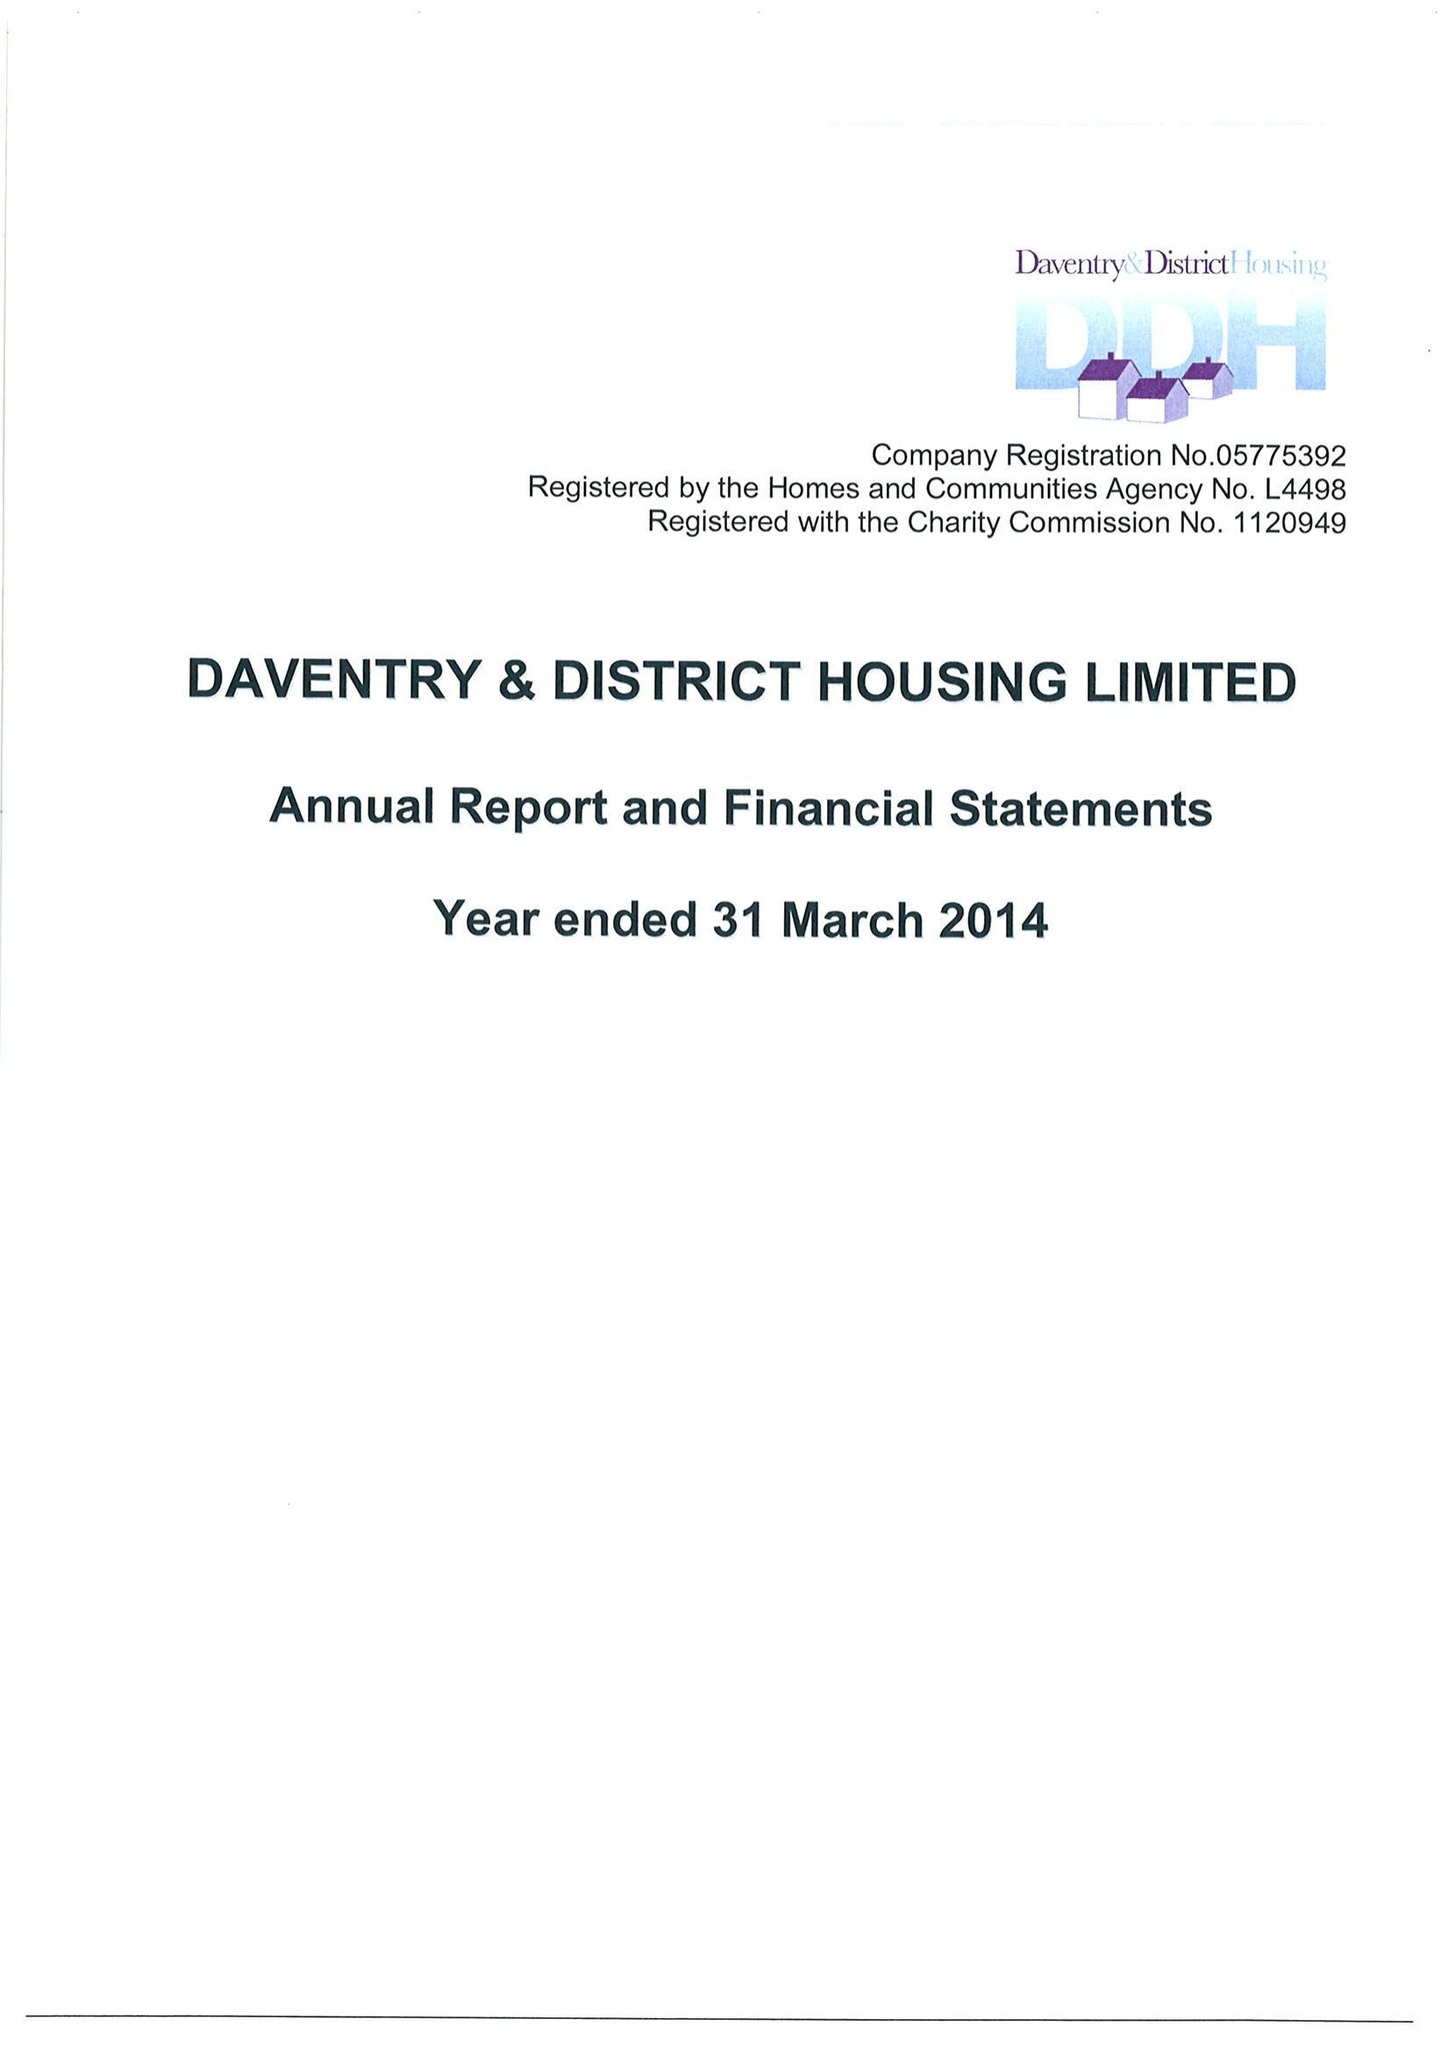What is the value for the charity_number?
Answer the question using a single word or phrase. 1120949 